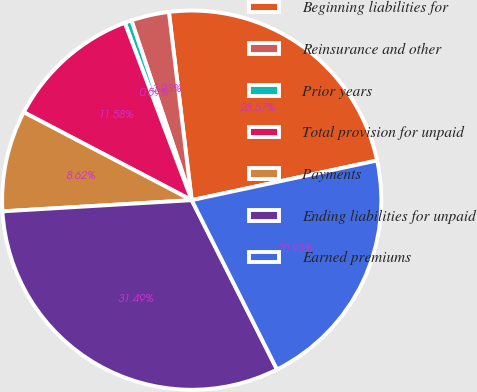Convert chart. <chart><loc_0><loc_0><loc_500><loc_500><pie_chart><fcel>Beginning liabilities for<fcel>Reinsurance and other<fcel>Prior years<fcel>Total provision for unpaid<fcel>Payments<fcel>Ending liabilities for unpaid<fcel>Earned premiums<nl><fcel>23.57%<fcel>3.23%<fcel>0.59%<fcel>11.58%<fcel>8.62%<fcel>31.49%<fcel>20.93%<nl></chart> 